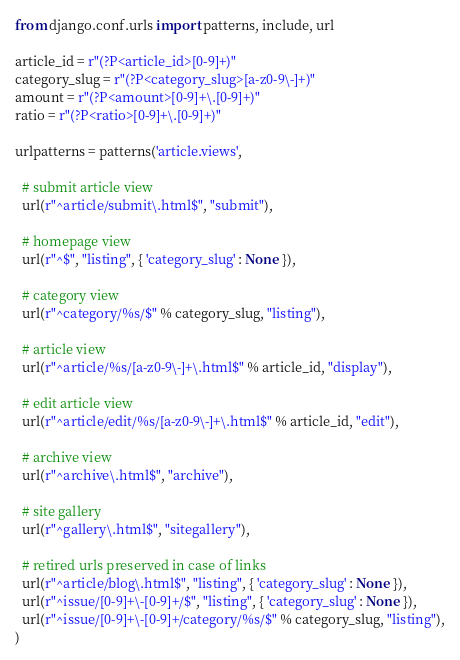<code> <loc_0><loc_0><loc_500><loc_500><_Python_>from django.conf.urls import patterns, include, url

article_id = r"(?P<article_id>[0-9]+)"
category_slug = r"(?P<category_slug>[a-z0-9\-]+)"
amount = r"(?P<amount>[0-9]+\.[0-9]+)"
ratio = r"(?P<ratio>[0-9]+\.[0-9]+)"

urlpatterns = patterns('article.views',
  
  # submit article view
  url(r"^article/submit\.html$", "submit"),

  # homepage view
  url(r"^$", "listing", { 'category_slug' : None }),
  
  # category view
  url(r"^category/%s/$" % category_slug, "listing"),

  # article view
  url(r"^article/%s/[a-z0-9\-]+\.html$" % article_id, "display"),

  # edit article view
  url(r"^article/edit/%s/[a-z0-9\-]+\.html$" % article_id, "edit"),

  # archive view
  url(r"^archive\.html$", "archive"),

  # site gallery
  url(r"^gallery\.html$", "sitegallery"),

  # retired urls preserved in case of links
  url(r"^article/blog\.html$", "listing", { 'category_slug' : None }),
  url(r"^issue/[0-9]+\-[0-9]+/$", "listing", { 'category_slug' : None }),
  url(r"^issue/[0-9]+\-[0-9]+/category/%s/$" % category_slug, "listing"),
)
</code> 